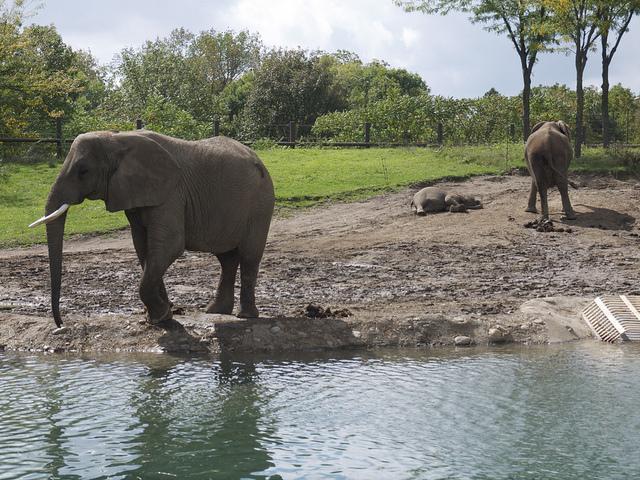How many elephants are laying down?
Give a very brief answer. 1. How many waves are in the water?
Give a very brief answer. 0. How many tails can you see in this picture?
Give a very brief answer. 2. How many elephants can you see?
Give a very brief answer. 2. 